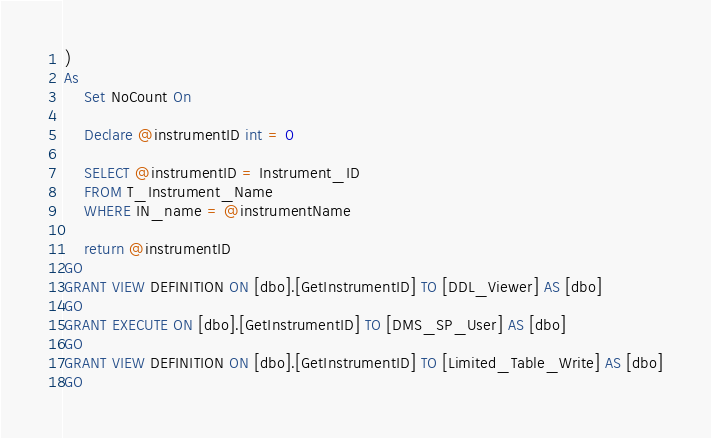Convert code to text. <code><loc_0><loc_0><loc_500><loc_500><_SQL_>)
As
	Set NoCount On
	
	Declare @instrumentID int = 0
	
	SELECT @instrumentID = Instrument_ID
	FROM T_Instrument_Name
	WHERE IN_name = @instrumentName

	return @instrumentID
GO
GRANT VIEW DEFINITION ON [dbo].[GetInstrumentID] TO [DDL_Viewer] AS [dbo]
GO
GRANT EXECUTE ON [dbo].[GetInstrumentID] TO [DMS_SP_User] AS [dbo]
GO
GRANT VIEW DEFINITION ON [dbo].[GetInstrumentID] TO [Limited_Table_Write] AS [dbo]
GO
</code> 